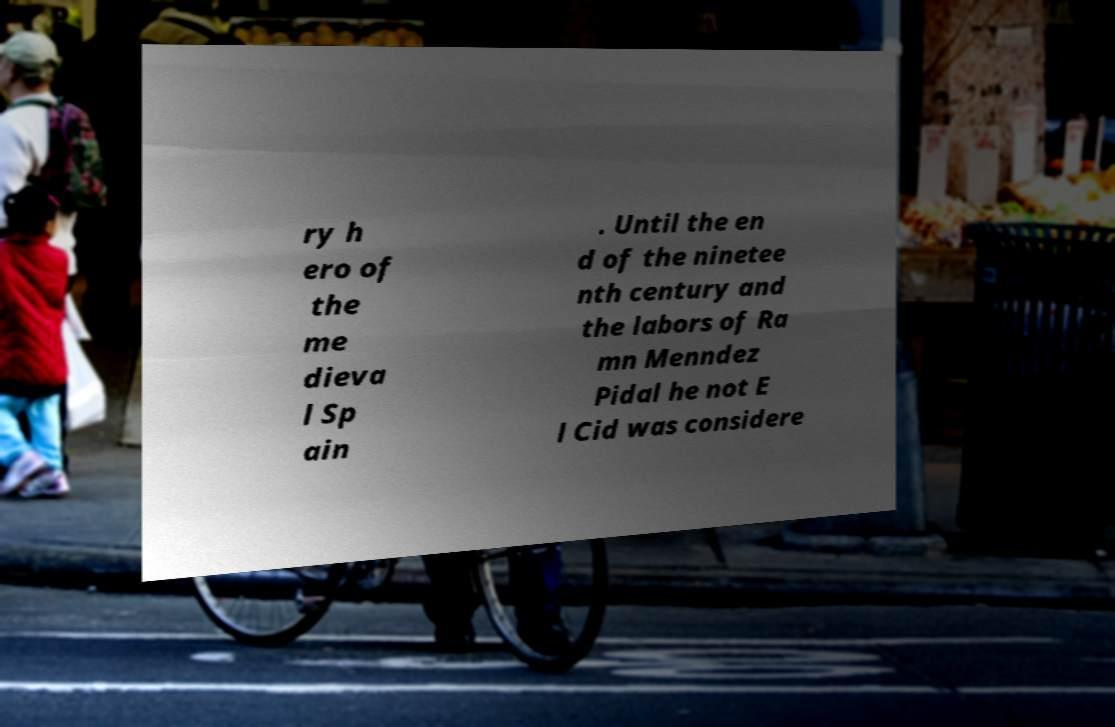Could you extract and type out the text from this image? ry h ero of the me dieva l Sp ain . Until the en d of the ninetee nth century and the labors of Ra mn Menndez Pidal he not E l Cid was considere 